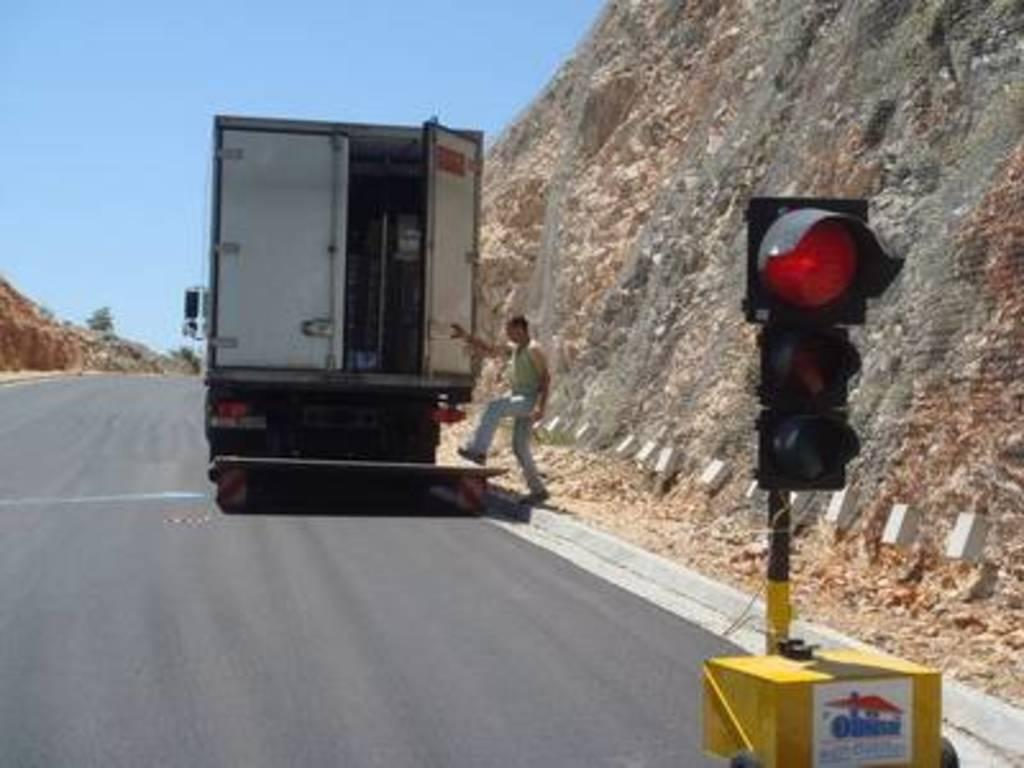What is the main subject of the image? The main subject of the image is a truck. Can you describe the person in the image? There is a person in the image, but their specific appearance or actions are not mentioned in the facts. What is located on the right side of the image? There is a traffic light on the right side of the image. What is visible at the top of the image? The sky is visible at the top of the image. What type of quilt is being used to cover the truck in the image? There is no quilt present in the image; it features a truck, a person, a traffic light, and the sky. What is the person's reaction to the traffic light in the image? The facts provided do not mention the person's reaction to the traffic light, so we cannot answer this question. 